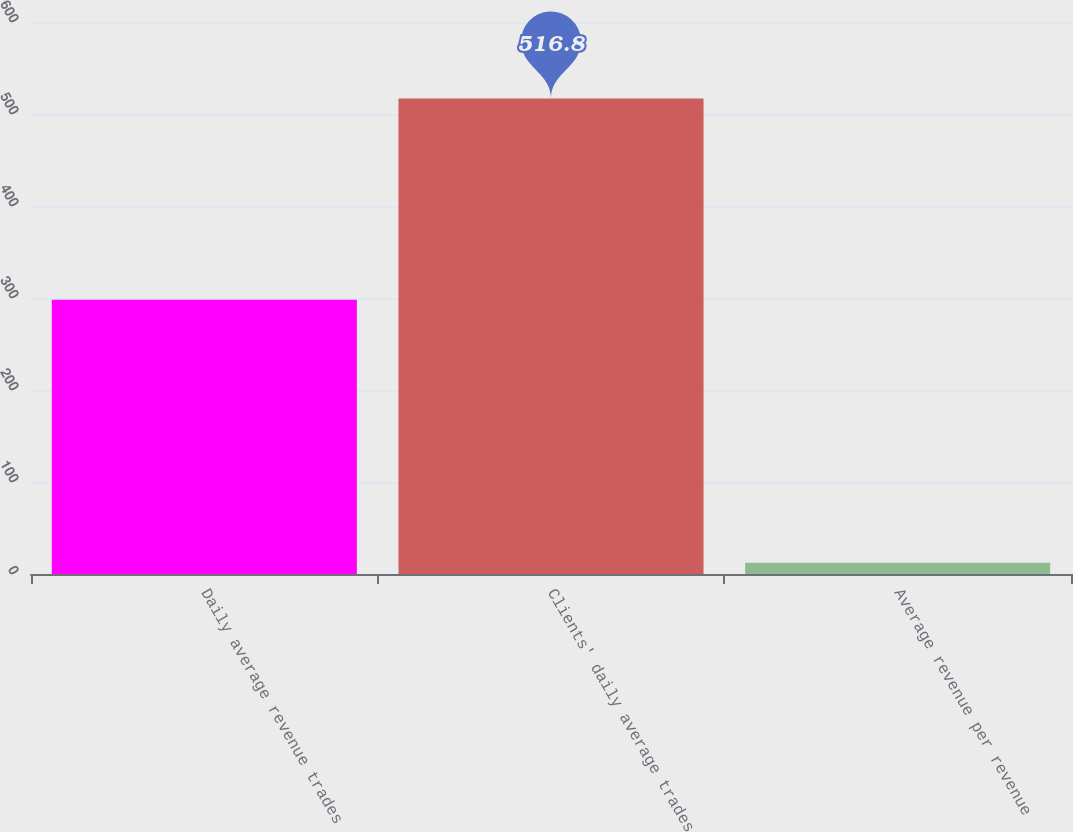<chart> <loc_0><loc_0><loc_500><loc_500><bar_chart><fcel>Daily average revenue trades<fcel>Clients' daily average trades<fcel>Average revenue per revenue<nl><fcel>298.2<fcel>516.8<fcel>12.13<nl></chart> 